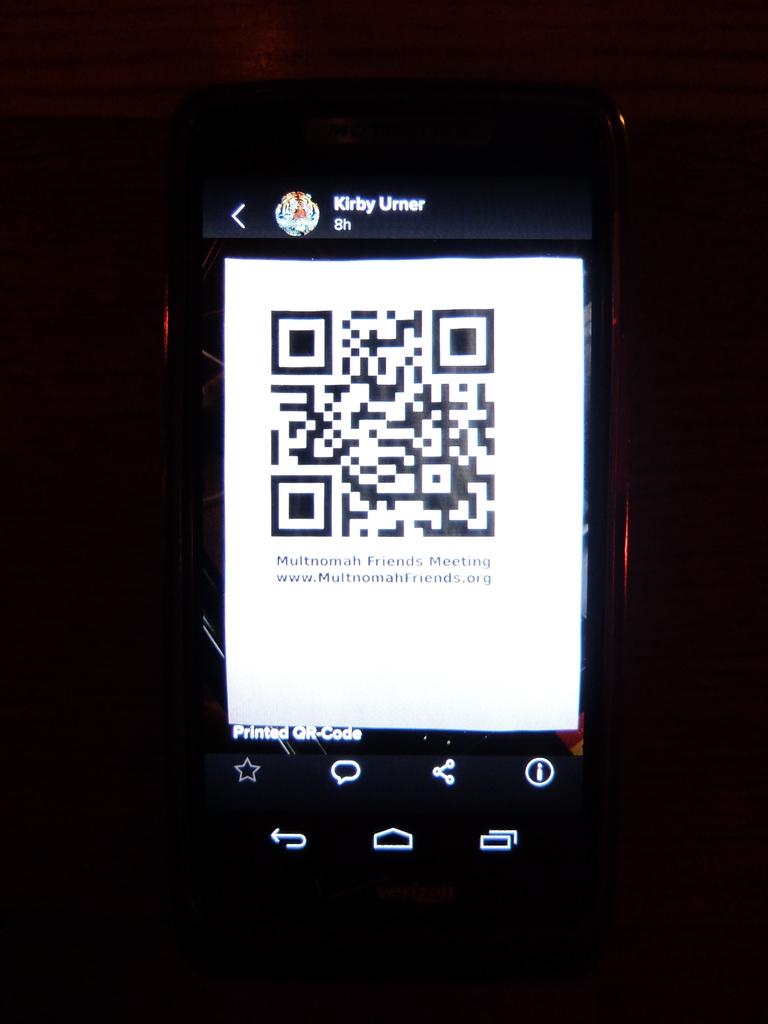Who is this qr code from?
Provide a short and direct response. Kirby urner. 